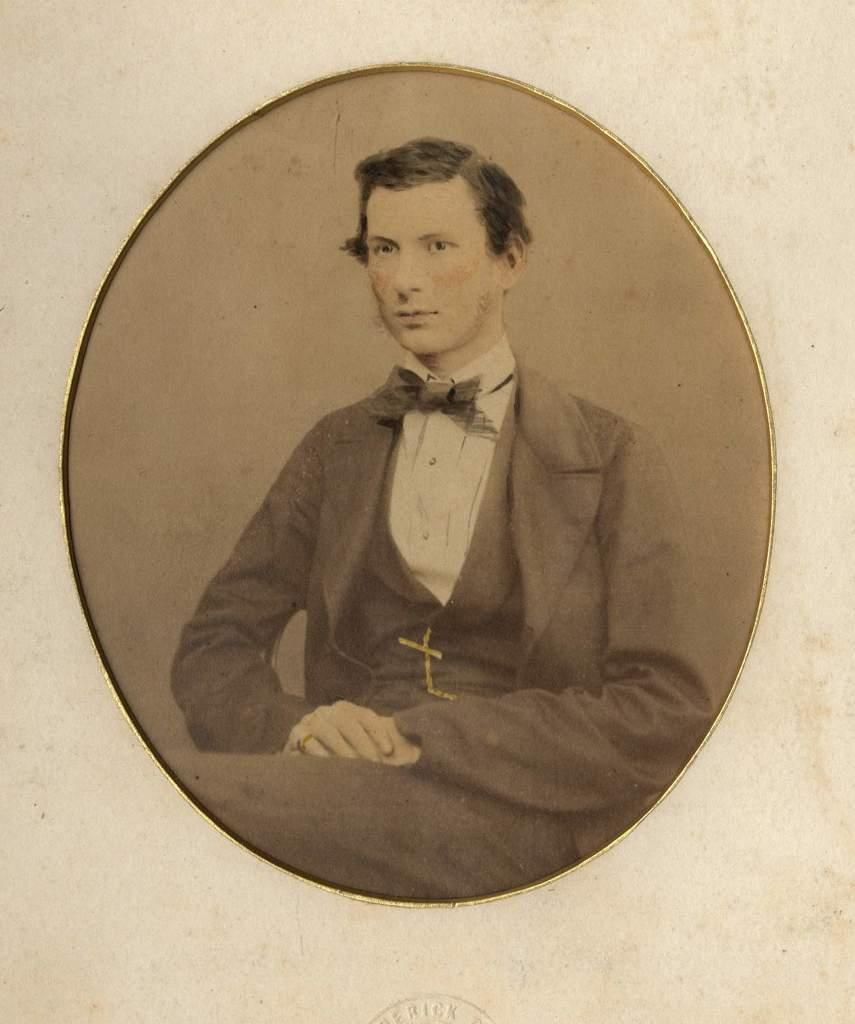What is the main subject of the image? There is a picture of a person sitting in the image. Is there any additional information or markings on the image? Yes, there is a stamp at the bottom of the image. What sense does the person sitting in the image lack? There is no indication in the image that the person sitting lacks any sense. 